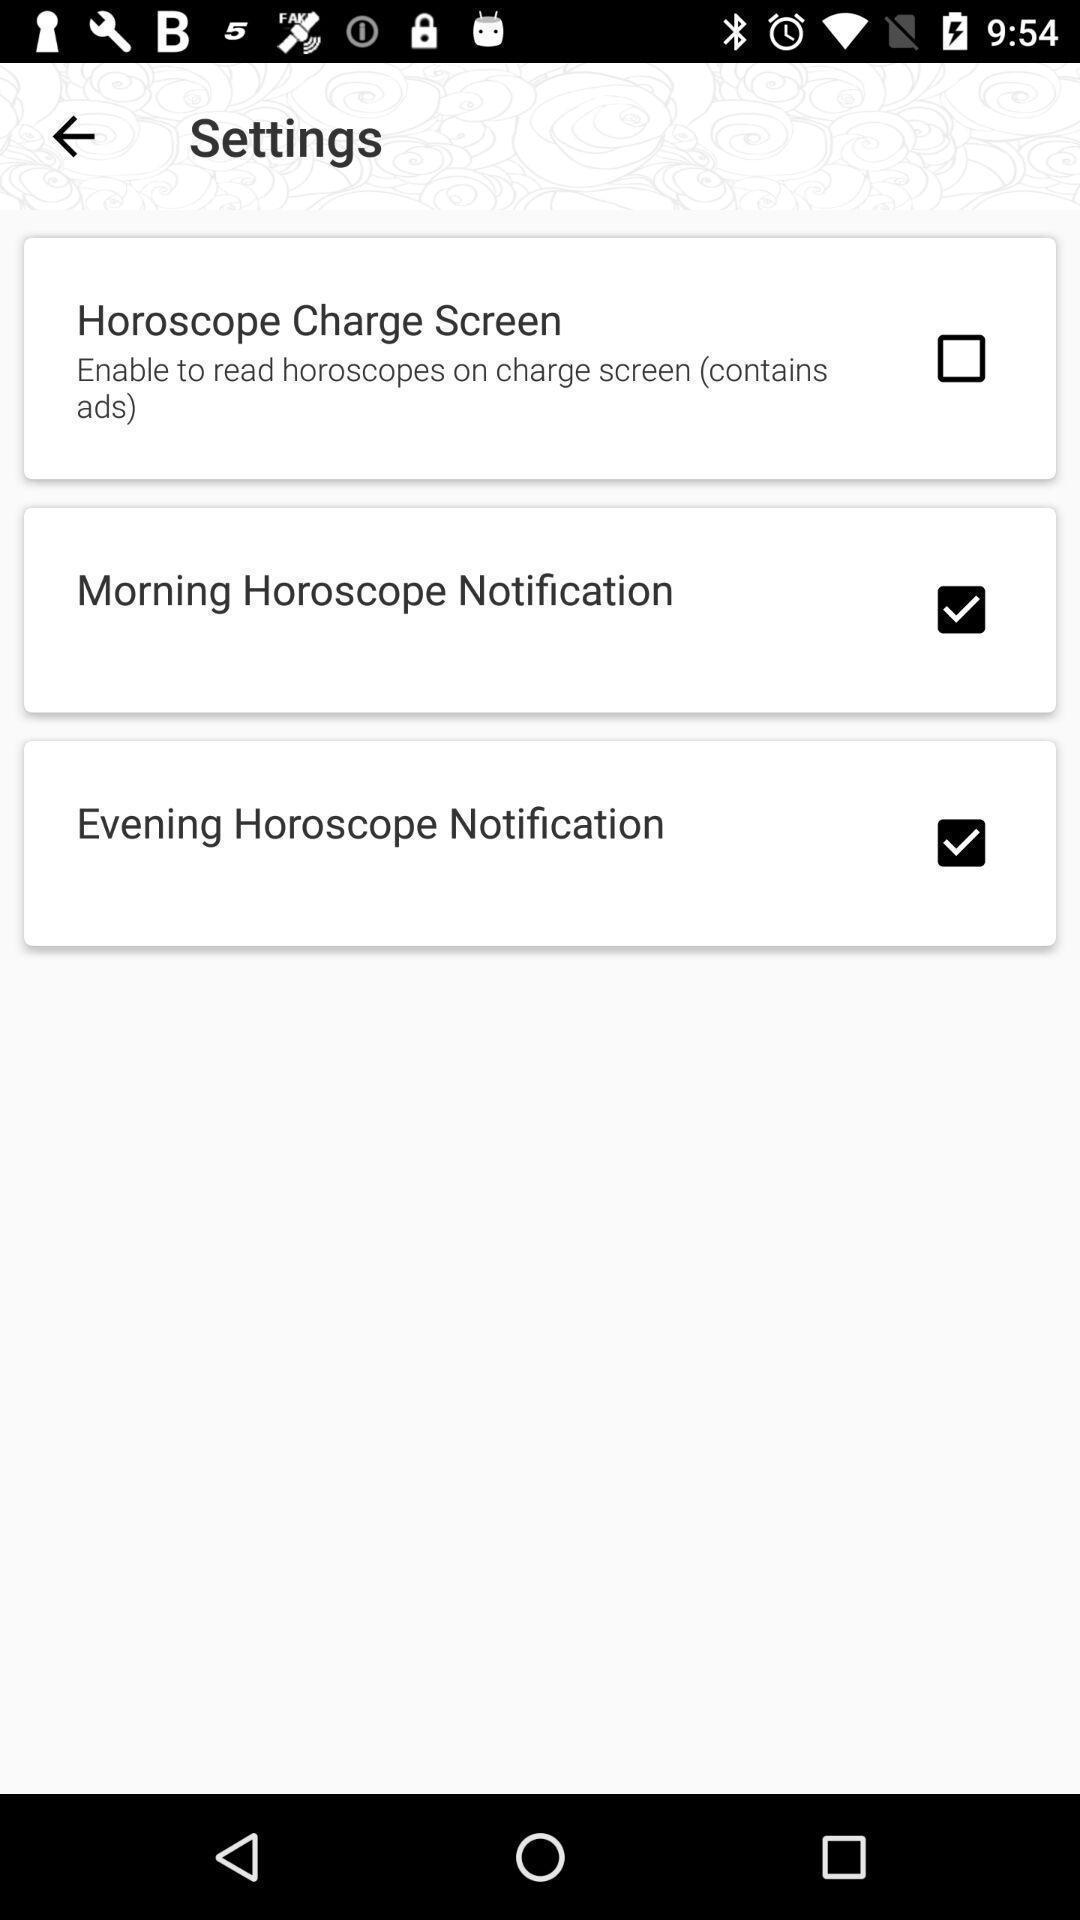Describe the visual elements of this screenshot. Settings page displayed of an horoscope app. 